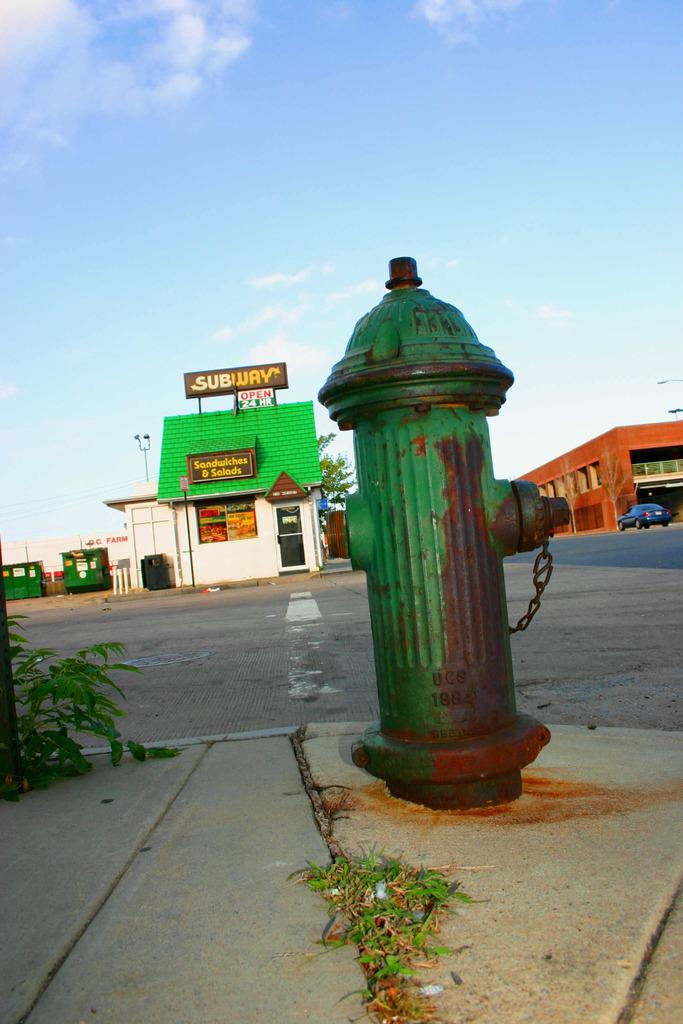<image>
Create a compact narrative representing the image presented. a Subway store that is on a green building 